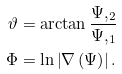<formula> <loc_0><loc_0><loc_500><loc_500>\vartheta & = \arctan \frac { \Psi , _ { 2 } } { \Psi , _ { 1 } } \\ \Phi & = \ln \left | \nabla \left ( \Psi \right ) \right | .</formula> 